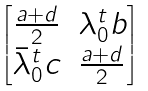Convert formula to latex. <formula><loc_0><loc_0><loc_500><loc_500>\begin{bmatrix} \frac { a + d } { 2 } & \lambda _ { 0 } ^ { t } b \\ \bar { \lambda } _ { 0 } ^ { t } c & \frac { a + d } { 2 } \end{bmatrix}</formula> 